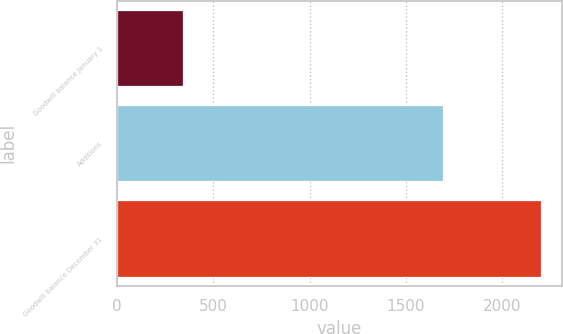Convert chart. <chart><loc_0><loc_0><loc_500><loc_500><bar_chart><fcel>Goodwill balance January 1<fcel>Additions<fcel>Goodwill balance December 31<nl><fcel>340<fcel>1693<fcel>2202.3<nl></chart> 